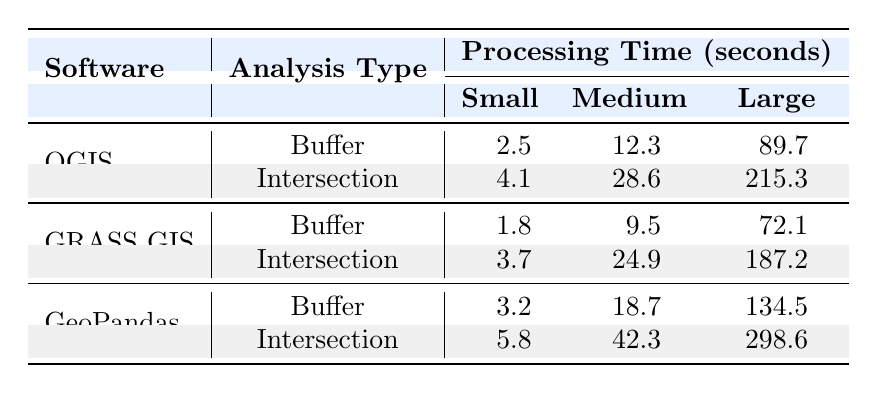What is the processing time for the Buffer analysis of a small dataset in QGIS? The table shows that for QGIS, the processing time for the Buffer analysis on a small dataset (1000 features) is 2.5 seconds.
Answer: 2.5 seconds Which software has the longest processing time for the Buffer analysis on a large dataset? Looking at the table, GeoPandas has the longest processing time for the Buffer analysis on a large dataset (100000 features), which is 134.5 seconds.
Answer: GeoPandas What is the difference in processing time between the Medium Buffer analysis in QGIS and GRASS GIS? The processing time for the Medium Buffer analysis in QGIS is 12.3 seconds and for GRASS GIS it is 9.5 seconds. The difference is 12.3 - 9.5 = 2.8 seconds.
Answer: 2.8 seconds Does GRASS GIS process the Intersection analysis of a small dataset faster than QGIS? For small datasets (1000 features), GRASS GIS has a processing time of 3.7 seconds while QGIS has 4.1 seconds. Therefore, GRASS GIS does process it faster.
Answer: Yes What is the average processing time for the Intersection analysis across all software for a Medium dataset? The processing times for the Medium Intersection analysis are: QGIS (28.6), GRASS GIS (24.9), and GeoPandas (42.3). Summing these gives 28.6 + 24.9 + 42.3 = 95.8 seconds. Dividing by 3 (the number of software) gives an average of 95.8 / 3 = 31.93 seconds.
Answer: 31.93 seconds Which analysis type has the shortest processing time for a large dataset in QGIS? The table indicates that QGIS takes 89.7 seconds for the Buffer analysis and 215.3 seconds for the Intersection analysis on a large dataset. Therefore, the Buffer analysis has the shortest processing time.
Answer: Buffer Is it true that the Medium Buffer analysis in GeoPandas takes more time than the Large Buffer analysis in GRASS GIS? The processing time for the Medium Buffer analysis in GeoPandas is 18.7 seconds while for the Large Buffer in GRASS GIS it is 72.1 seconds. 18.7 is less than 72.1 which makes this statement false.
Answer: No What is the total processing time for the Buffer analysis across all software for a small dataset? The processing times for the small Buffer analysis are: QGIS (2.5), GRASS GIS (1.8), and GeoPandas (3.2). Adding these gives a total of 2.5 + 1.8 + 3.2 = 7.5 seconds.
Answer: 7.5 seconds 